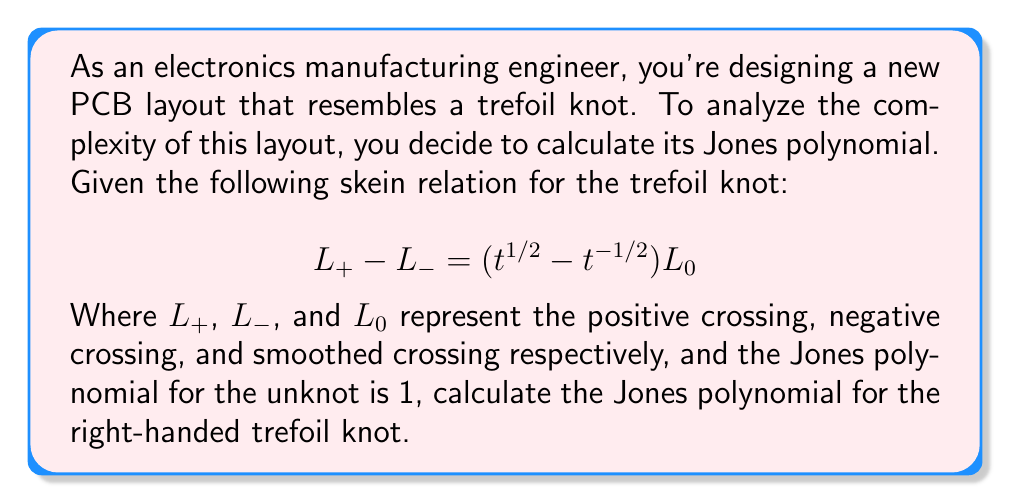What is the answer to this math problem? Let's approach this step-by-step:

1) First, we need to recognize that the right-handed trefoil knot has three positive crossings.

2) We'll use the skein relation repeatedly to simplify the knot:

   $$L_+ = L_- + (t^{1/2} - t^{-1/2})L_0$$

3) After one application of the skein relation, we get:

   $$V(\text{trefoil}) = tV(\text{Hopf link}) + t^{3/2}V(\text{unknot})$$

   Where $V(\text{unknot}) = 1$

4) The Hopf link can be further simplified using the skein relation:

   $$V(\text{Hopf link}) = t^{-1}V(\text{2 unlinked circles}) + t^{-1/2}V(\text{unknot})$$

5) We know that $V(\text{2 unlinked circles}) = -t^{1/2} - t^{-1/2}$ and $V(\text{unknot}) = 1$

6) Substituting these values:

   $$V(\text{Hopf link}) = t^{-1}(-t^{1/2} - t^{-1/2}) + t^{-1/2}$$
   $$= -t^{-1/2} - t^{-3/2} + t^{-1/2} = -t^{-3/2}$$

7) Now, let's substitute this back into our original equation:

   $$V(\text{trefoil}) = t(-t^{-3/2}) + t^{3/2}$$
   $$= -t^{-1/2} + t^{3/2}$$

8) Simplify:

   $$V(\text{trefoil}) = t^{-1} - 1 + t$$

This is the Jones polynomial for the right-handed trefoil knot.
Answer: $t^{-1} - 1 + t$ 